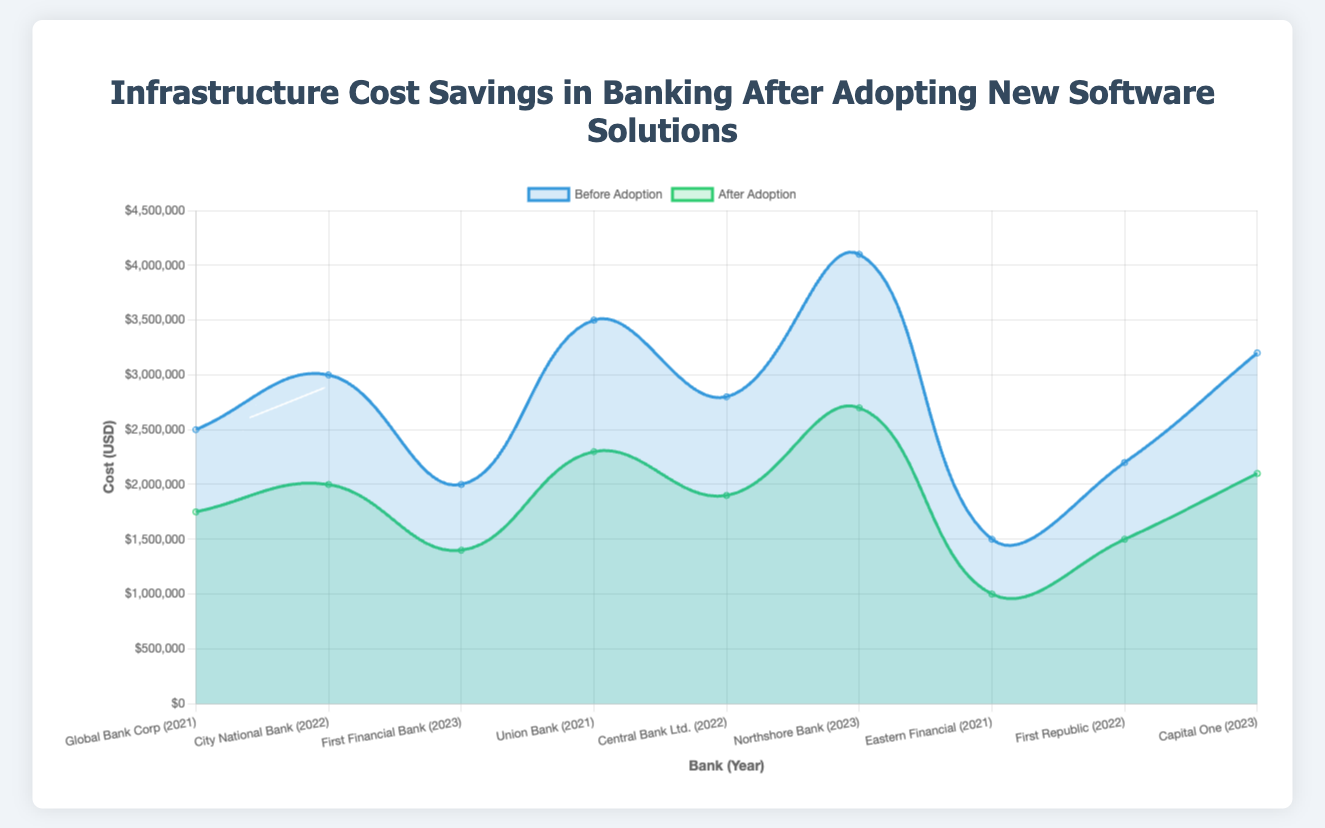How much did Union Bank save in infrastructure costs after adopting the cybersecurity solution? Union Bank's cost before adoption is $3,500,000 and after adoption is $2,300,000. The difference is $3,500,000 - $2,300,000 = $1,200,000.
Answer: $1,200,000 Which bank achieved the highest cost savings using the CRM solution? The cost savings are calculated from the differences for each bank using the CRM solution. Global Bank Corp: $2,500,000 - $1,750,000 = $750,000, City National Bank: $3,000,000 - $2,000,000 = $1,000,000, First Financial Bank: $2,000,000 - $1,400,000 = $600,000. City National Bank saved the most with $1,000,000.
Answer: City National Bank What is the total cost savings for banks using data analytics solutions in 2023? Only Capital One used data analytics in 2023. Before adoption: $3,200,000, After adoption: $2,100,000. The savings are $3,200,000 - $2,100,000 = $1,100,000.
Answer: $1,100,000 Comparing the cost savings between CRM and cybersecurity solutions for the year 2022, which solution type offered higher savings on average? For CRM (2022): City National Bank's savings are $1,000,000. For Cybersecurity (2022): Central Bank Ltd.'s savings are $2,800,000 - $1,900,000 = $900,000. The average for CRM (2022) is $1,000,000 and for Cybersecurity (2022) is $900,000. CRM had higher average savings.
Answer: CRM What is the percentage reduction in costs for First Financial Bank after adopting the CRM solution in 2023? The original cost is $2,000,000 and the cost after adoption is $1,400,000. Percentage reduction is calculated as (($2,000,000 - $1,400,000) / $2,000,000) * 100 = 30%.
Answer: 30% Which solution type provided the greatest cost savings across all banks and years? The total savings for each solution type is calculated. CRM: $750,000 + $1,000,000 + $600,000 = $2,350,000, Cybersecurity: $1,200,000 + $900,000 + $1,400,000 = $3,500,000, Data Analytics: $500,000 + $700,000 + $1,100,000 = $2,300,000. Cybersecurity provided the greatest total savings of $3,500,000.
Answer: Cybersecurity What are the cost savings for the banks using cybersecurity solutions in 2023 combined? Northshore Bank is the only bank using cybersecurity in 2023. Cost savings are $4,100,000 - $2,700,000 = $1,400,000.
Answer: $1,400,000 